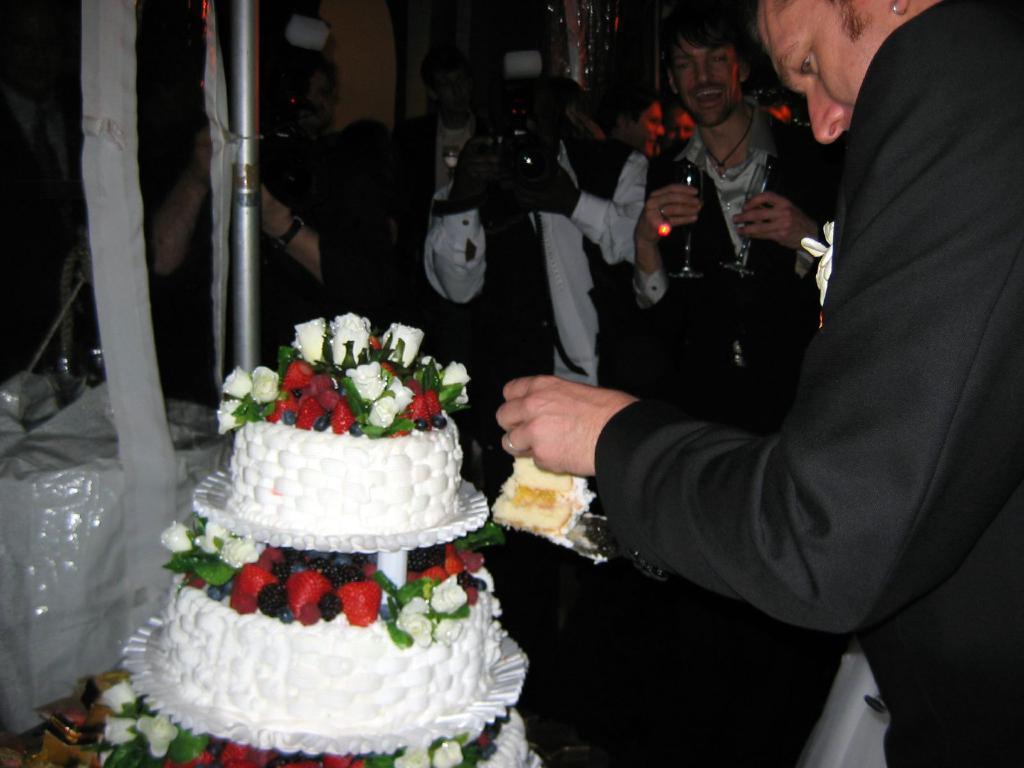Could you give a brief overview of what you see in this image? In this picture there is a person standing on the right side of the image is holding the cake and knife. At the back there is a person standing and holding the glasses and there is a person standing and holding the camera. At the back there are group of people standing. In the foreground there is a cake and box on the table 